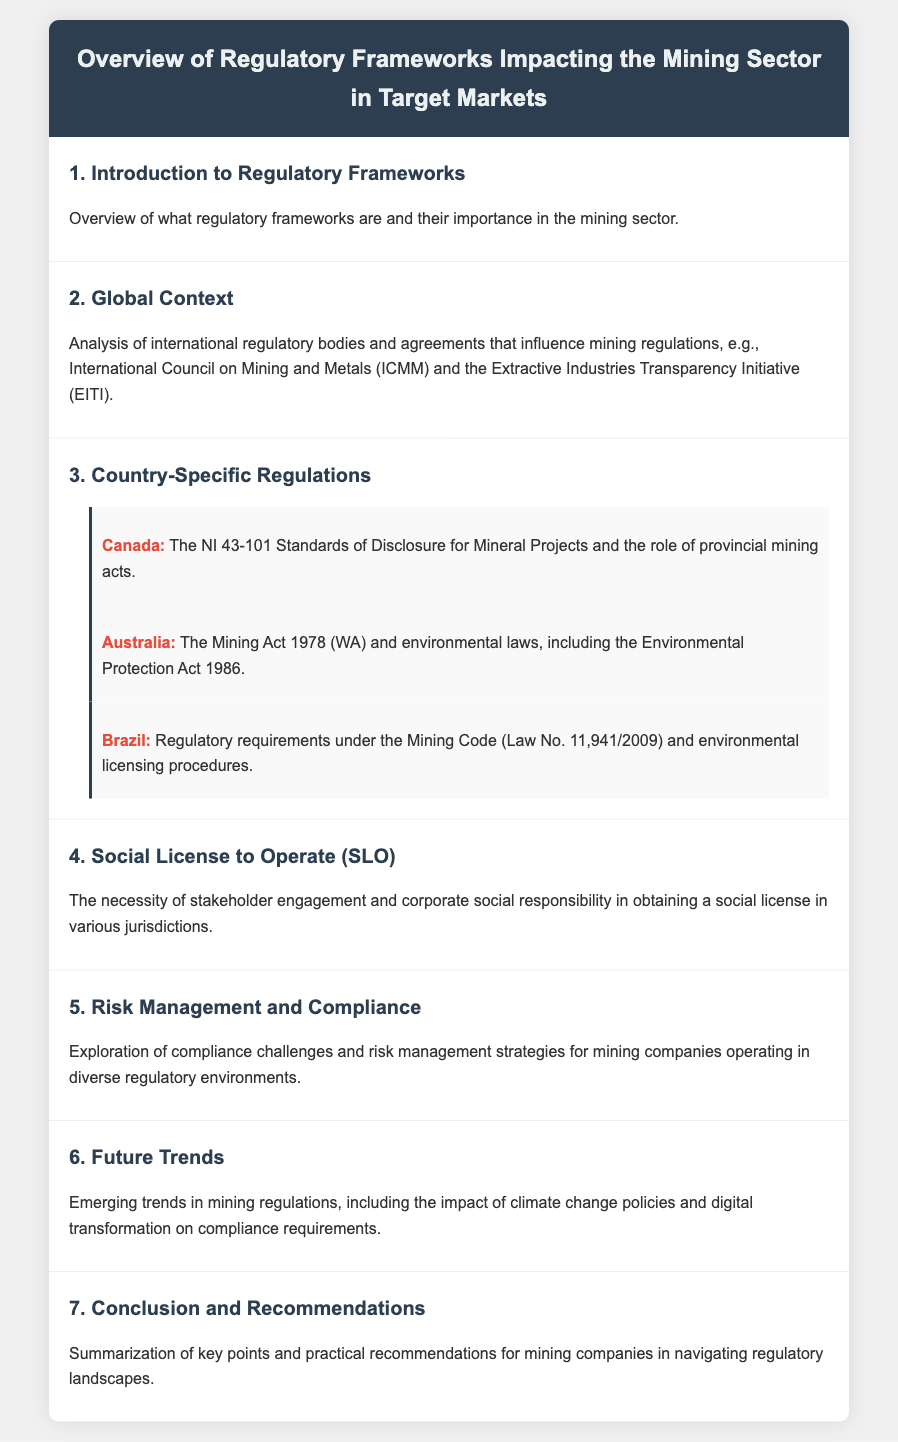What is the title of the document? The title of the document is displayed prominently at the top of the rendered agenda.
Answer: Overview of Regulatory Frameworks Impacting the Mining Sector in Target Markets Who is a notable international regulatory body mentioned in the document? The document lists international regulatory bodies that influence mining regulations, including one specific example.
Answer: International Council on Mining and Metals (ICMM) Which country follows the NI 43-101 Standards of Disclosure? The document specifies regulations for different countries, including one that follows these standards.
Answer: Canada What does "SLO" stand for in the context of the document? The acronym is introduced in the agenda and explained in relation to stakeholder engagement.
Answer: Social License to Operate What is the focus of section 6 in the document? Section 6 addresses emerging trends in mining regulations based on a specific thematic focus.
Answer: Future Trends What environmental law is associated with Australia in this document? The agenda highlights specific environmental laws relevant to Australia within the context of mining.
Answer: Environmental Protection Act 1986 Which regulatory framework is discussed for Brazil? The document indicates the specific legal code that governs mining regulations in Brazil.
Answer: Mining Code (Law No. 11,941/2009) 